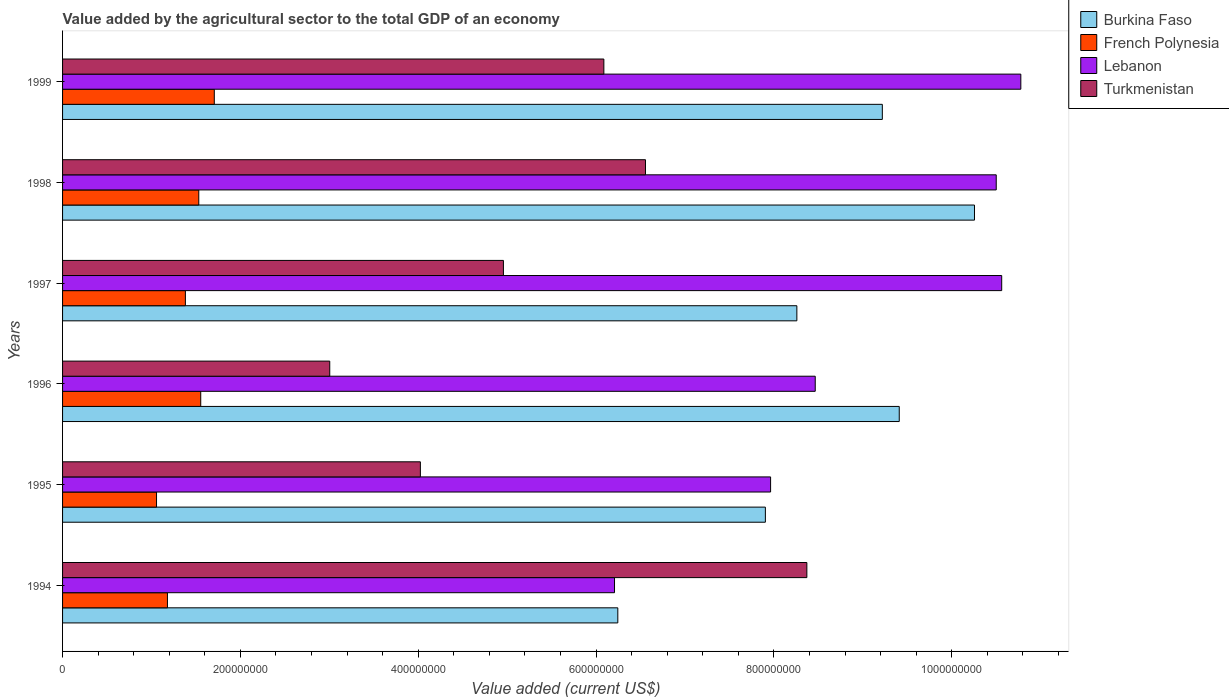How many different coloured bars are there?
Your answer should be very brief. 4. Are the number of bars per tick equal to the number of legend labels?
Keep it short and to the point. Yes. Are the number of bars on each tick of the Y-axis equal?
Your answer should be compact. Yes. How many bars are there on the 1st tick from the top?
Your response must be concise. 4. In how many cases, is the number of bars for a given year not equal to the number of legend labels?
Give a very brief answer. 0. What is the value added by the agricultural sector to the total GDP in Burkina Faso in 1995?
Offer a very short reply. 7.90e+08. Across all years, what is the maximum value added by the agricultural sector to the total GDP in French Polynesia?
Your answer should be compact. 1.71e+08. Across all years, what is the minimum value added by the agricultural sector to the total GDP in French Polynesia?
Provide a short and direct response. 1.06e+08. What is the total value added by the agricultural sector to the total GDP in French Polynesia in the graph?
Give a very brief answer. 8.41e+08. What is the difference between the value added by the agricultural sector to the total GDP in French Polynesia in 1998 and that in 1999?
Offer a very short reply. -1.75e+07. What is the difference between the value added by the agricultural sector to the total GDP in Burkina Faso in 1998 and the value added by the agricultural sector to the total GDP in Turkmenistan in 1999?
Ensure brevity in your answer.  4.17e+08. What is the average value added by the agricultural sector to the total GDP in Burkina Faso per year?
Make the answer very short. 8.55e+08. In the year 1998, what is the difference between the value added by the agricultural sector to the total GDP in Turkmenistan and value added by the agricultural sector to the total GDP in Burkina Faso?
Your answer should be compact. -3.70e+08. In how many years, is the value added by the agricultural sector to the total GDP in Turkmenistan greater than 960000000 US$?
Ensure brevity in your answer.  0. What is the ratio of the value added by the agricultural sector to the total GDP in Lebanon in 1994 to that in 1997?
Give a very brief answer. 0.59. Is the value added by the agricultural sector to the total GDP in French Polynesia in 1994 less than that in 1997?
Keep it short and to the point. Yes. What is the difference between the highest and the second highest value added by the agricultural sector to the total GDP in Burkina Faso?
Your response must be concise. 8.46e+07. What is the difference between the highest and the lowest value added by the agricultural sector to the total GDP in French Polynesia?
Provide a short and direct response. 6.50e+07. Is the sum of the value added by the agricultural sector to the total GDP in Burkina Faso in 1997 and 1999 greater than the maximum value added by the agricultural sector to the total GDP in Turkmenistan across all years?
Make the answer very short. Yes. What does the 1st bar from the top in 1999 represents?
Provide a succinct answer. Turkmenistan. What does the 3rd bar from the bottom in 1997 represents?
Your answer should be very brief. Lebanon. Are all the bars in the graph horizontal?
Make the answer very short. Yes. What is the difference between two consecutive major ticks on the X-axis?
Offer a terse response. 2.00e+08. Are the values on the major ticks of X-axis written in scientific E-notation?
Keep it short and to the point. No. Does the graph contain grids?
Offer a terse response. No. Where does the legend appear in the graph?
Give a very brief answer. Top right. What is the title of the graph?
Keep it short and to the point. Value added by the agricultural sector to the total GDP of an economy. What is the label or title of the X-axis?
Your answer should be very brief. Value added (current US$). What is the Value added (current US$) of Burkina Faso in 1994?
Your answer should be compact. 6.24e+08. What is the Value added (current US$) of French Polynesia in 1994?
Your response must be concise. 1.18e+08. What is the Value added (current US$) of Lebanon in 1994?
Offer a very short reply. 6.21e+08. What is the Value added (current US$) in Turkmenistan in 1994?
Provide a short and direct response. 8.37e+08. What is the Value added (current US$) in Burkina Faso in 1995?
Offer a very short reply. 7.90e+08. What is the Value added (current US$) of French Polynesia in 1995?
Provide a succinct answer. 1.06e+08. What is the Value added (current US$) of Lebanon in 1995?
Offer a terse response. 7.96e+08. What is the Value added (current US$) of Turkmenistan in 1995?
Your response must be concise. 4.02e+08. What is the Value added (current US$) of Burkina Faso in 1996?
Offer a terse response. 9.41e+08. What is the Value added (current US$) in French Polynesia in 1996?
Provide a short and direct response. 1.55e+08. What is the Value added (current US$) in Lebanon in 1996?
Offer a very short reply. 8.46e+08. What is the Value added (current US$) in Turkmenistan in 1996?
Your answer should be compact. 3.00e+08. What is the Value added (current US$) in Burkina Faso in 1997?
Offer a terse response. 8.26e+08. What is the Value added (current US$) of French Polynesia in 1997?
Ensure brevity in your answer.  1.38e+08. What is the Value added (current US$) of Lebanon in 1997?
Offer a terse response. 1.06e+09. What is the Value added (current US$) in Turkmenistan in 1997?
Provide a succinct answer. 4.96e+08. What is the Value added (current US$) in Burkina Faso in 1998?
Your answer should be compact. 1.03e+09. What is the Value added (current US$) in French Polynesia in 1998?
Ensure brevity in your answer.  1.53e+08. What is the Value added (current US$) in Lebanon in 1998?
Keep it short and to the point. 1.05e+09. What is the Value added (current US$) of Turkmenistan in 1998?
Make the answer very short. 6.56e+08. What is the Value added (current US$) of Burkina Faso in 1999?
Ensure brevity in your answer.  9.22e+08. What is the Value added (current US$) of French Polynesia in 1999?
Give a very brief answer. 1.71e+08. What is the Value added (current US$) of Lebanon in 1999?
Keep it short and to the point. 1.08e+09. What is the Value added (current US$) in Turkmenistan in 1999?
Keep it short and to the point. 6.09e+08. Across all years, what is the maximum Value added (current US$) in Burkina Faso?
Keep it short and to the point. 1.03e+09. Across all years, what is the maximum Value added (current US$) of French Polynesia?
Offer a very short reply. 1.71e+08. Across all years, what is the maximum Value added (current US$) of Lebanon?
Make the answer very short. 1.08e+09. Across all years, what is the maximum Value added (current US$) of Turkmenistan?
Your answer should be very brief. 8.37e+08. Across all years, what is the minimum Value added (current US$) in Burkina Faso?
Give a very brief answer. 6.24e+08. Across all years, what is the minimum Value added (current US$) of French Polynesia?
Make the answer very short. 1.06e+08. Across all years, what is the minimum Value added (current US$) of Lebanon?
Your response must be concise. 6.21e+08. Across all years, what is the minimum Value added (current US$) of Turkmenistan?
Your response must be concise. 3.00e+08. What is the total Value added (current US$) in Burkina Faso in the graph?
Offer a terse response. 5.13e+09. What is the total Value added (current US$) in French Polynesia in the graph?
Offer a very short reply. 8.41e+08. What is the total Value added (current US$) in Lebanon in the graph?
Your answer should be compact. 5.45e+09. What is the total Value added (current US$) in Turkmenistan in the graph?
Keep it short and to the point. 3.30e+09. What is the difference between the Value added (current US$) in Burkina Faso in 1994 and that in 1995?
Your answer should be very brief. -1.66e+08. What is the difference between the Value added (current US$) of French Polynesia in 1994 and that in 1995?
Your response must be concise. 1.23e+07. What is the difference between the Value added (current US$) in Lebanon in 1994 and that in 1995?
Your answer should be very brief. -1.76e+08. What is the difference between the Value added (current US$) of Turkmenistan in 1994 and that in 1995?
Offer a very short reply. 4.35e+08. What is the difference between the Value added (current US$) of Burkina Faso in 1994 and that in 1996?
Give a very brief answer. -3.17e+08. What is the difference between the Value added (current US$) in French Polynesia in 1994 and that in 1996?
Keep it short and to the point. -3.74e+07. What is the difference between the Value added (current US$) of Lebanon in 1994 and that in 1996?
Ensure brevity in your answer.  -2.26e+08. What is the difference between the Value added (current US$) in Turkmenistan in 1994 and that in 1996?
Provide a succinct answer. 5.37e+08. What is the difference between the Value added (current US$) of Burkina Faso in 1994 and that in 1997?
Provide a succinct answer. -2.01e+08. What is the difference between the Value added (current US$) in French Polynesia in 1994 and that in 1997?
Make the answer very short. -2.02e+07. What is the difference between the Value added (current US$) in Lebanon in 1994 and that in 1997?
Your answer should be very brief. -4.35e+08. What is the difference between the Value added (current US$) of Turkmenistan in 1994 and that in 1997?
Give a very brief answer. 3.41e+08. What is the difference between the Value added (current US$) of Burkina Faso in 1994 and that in 1998?
Your answer should be very brief. -4.01e+08. What is the difference between the Value added (current US$) of French Polynesia in 1994 and that in 1998?
Ensure brevity in your answer.  -3.52e+07. What is the difference between the Value added (current US$) in Lebanon in 1994 and that in 1998?
Keep it short and to the point. -4.29e+08. What is the difference between the Value added (current US$) of Turkmenistan in 1994 and that in 1998?
Your answer should be very brief. 1.81e+08. What is the difference between the Value added (current US$) in Burkina Faso in 1994 and that in 1999?
Provide a succinct answer. -2.97e+08. What is the difference between the Value added (current US$) in French Polynesia in 1994 and that in 1999?
Your answer should be very brief. -5.27e+07. What is the difference between the Value added (current US$) of Lebanon in 1994 and that in 1999?
Offer a terse response. -4.57e+08. What is the difference between the Value added (current US$) in Turkmenistan in 1994 and that in 1999?
Make the answer very short. 2.28e+08. What is the difference between the Value added (current US$) of Burkina Faso in 1995 and that in 1996?
Make the answer very short. -1.51e+08. What is the difference between the Value added (current US$) in French Polynesia in 1995 and that in 1996?
Your answer should be very brief. -4.97e+07. What is the difference between the Value added (current US$) in Lebanon in 1995 and that in 1996?
Your answer should be very brief. -5.02e+07. What is the difference between the Value added (current US$) in Turkmenistan in 1995 and that in 1996?
Provide a succinct answer. 1.02e+08. What is the difference between the Value added (current US$) of Burkina Faso in 1995 and that in 1997?
Keep it short and to the point. -3.54e+07. What is the difference between the Value added (current US$) in French Polynesia in 1995 and that in 1997?
Give a very brief answer. -3.25e+07. What is the difference between the Value added (current US$) of Lebanon in 1995 and that in 1997?
Provide a succinct answer. -2.60e+08. What is the difference between the Value added (current US$) in Turkmenistan in 1995 and that in 1997?
Offer a terse response. -9.34e+07. What is the difference between the Value added (current US$) in Burkina Faso in 1995 and that in 1998?
Offer a very short reply. -2.35e+08. What is the difference between the Value added (current US$) in French Polynesia in 1995 and that in 1998?
Give a very brief answer. -4.75e+07. What is the difference between the Value added (current US$) of Lebanon in 1995 and that in 1998?
Your response must be concise. -2.54e+08. What is the difference between the Value added (current US$) in Turkmenistan in 1995 and that in 1998?
Give a very brief answer. -2.53e+08. What is the difference between the Value added (current US$) of Burkina Faso in 1995 and that in 1999?
Provide a short and direct response. -1.32e+08. What is the difference between the Value added (current US$) in French Polynesia in 1995 and that in 1999?
Give a very brief answer. -6.50e+07. What is the difference between the Value added (current US$) in Lebanon in 1995 and that in 1999?
Offer a terse response. -2.81e+08. What is the difference between the Value added (current US$) of Turkmenistan in 1995 and that in 1999?
Provide a short and direct response. -2.06e+08. What is the difference between the Value added (current US$) of Burkina Faso in 1996 and that in 1997?
Provide a succinct answer. 1.15e+08. What is the difference between the Value added (current US$) in French Polynesia in 1996 and that in 1997?
Provide a short and direct response. 1.73e+07. What is the difference between the Value added (current US$) in Lebanon in 1996 and that in 1997?
Ensure brevity in your answer.  -2.10e+08. What is the difference between the Value added (current US$) in Turkmenistan in 1996 and that in 1997?
Your response must be concise. -1.95e+08. What is the difference between the Value added (current US$) of Burkina Faso in 1996 and that in 1998?
Provide a short and direct response. -8.46e+07. What is the difference between the Value added (current US$) in French Polynesia in 1996 and that in 1998?
Your response must be concise. 2.21e+06. What is the difference between the Value added (current US$) in Lebanon in 1996 and that in 1998?
Offer a very short reply. -2.04e+08. What is the difference between the Value added (current US$) in Turkmenistan in 1996 and that in 1998?
Offer a terse response. -3.55e+08. What is the difference between the Value added (current US$) in Burkina Faso in 1996 and that in 1999?
Offer a very short reply. 1.90e+07. What is the difference between the Value added (current US$) of French Polynesia in 1996 and that in 1999?
Your answer should be very brief. -1.52e+07. What is the difference between the Value added (current US$) in Lebanon in 1996 and that in 1999?
Offer a very short reply. -2.31e+08. What is the difference between the Value added (current US$) in Turkmenistan in 1996 and that in 1999?
Keep it short and to the point. -3.08e+08. What is the difference between the Value added (current US$) in Burkina Faso in 1997 and that in 1998?
Your answer should be very brief. -2.00e+08. What is the difference between the Value added (current US$) of French Polynesia in 1997 and that in 1998?
Provide a short and direct response. -1.50e+07. What is the difference between the Value added (current US$) in Lebanon in 1997 and that in 1998?
Your answer should be very brief. 6.15e+06. What is the difference between the Value added (current US$) in Turkmenistan in 1997 and that in 1998?
Offer a terse response. -1.60e+08. What is the difference between the Value added (current US$) of Burkina Faso in 1997 and that in 1999?
Provide a short and direct response. -9.61e+07. What is the difference between the Value added (current US$) in French Polynesia in 1997 and that in 1999?
Keep it short and to the point. -3.25e+07. What is the difference between the Value added (current US$) of Lebanon in 1997 and that in 1999?
Ensure brevity in your answer.  -2.15e+07. What is the difference between the Value added (current US$) of Turkmenistan in 1997 and that in 1999?
Ensure brevity in your answer.  -1.13e+08. What is the difference between the Value added (current US$) of Burkina Faso in 1998 and that in 1999?
Give a very brief answer. 1.04e+08. What is the difference between the Value added (current US$) of French Polynesia in 1998 and that in 1999?
Your answer should be compact. -1.75e+07. What is the difference between the Value added (current US$) in Lebanon in 1998 and that in 1999?
Your response must be concise. -2.77e+07. What is the difference between the Value added (current US$) in Turkmenistan in 1998 and that in 1999?
Ensure brevity in your answer.  4.68e+07. What is the difference between the Value added (current US$) in Burkina Faso in 1994 and the Value added (current US$) in French Polynesia in 1995?
Give a very brief answer. 5.19e+08. What is the difference between the Value added (current US$) in Burkina Faso in 1994 and the Value added (current US$) in Lebanon in 1995?
Offer a terse response. -1.72e+08. What is the difference between the Value added (current US$) of Burkina Faso in 1994 and the Value added (current US$) of Turkmenistan in 1995?
Ensure brevity in your answer.  2.22e+08. What is the difference between the Value added (current US$) in French Polynesia in 1994 and the Value added (current US$) in Lebanon in 1995?
Make the answer very short. -6.78e+08. What is the difference between the Value added (current US$) of French Polynesia in 1994 and the Value added (current US$) of Turkmenistan in 1995?
Keep it short and to the point. -2.84e+08. What is the difference between the Value added (current US$) of Lebanon in 1994 and the Value added (current US$) of Turkmenistan in 1995?
Ensure brevity in your answer.  2.18e+08. What is the difference between the Value added (current US$) in Burkina Faso in 1994 and the Value added (current US$) in French Polynesia in 1996?
Give a very brief answer. 4.69e+08. What is the difference between the Value added (current US$) in Burkina Faso in 1994 and the Value added (current US$) in Lebanon in 1996?
Provide a succinct answer. -2.22e+08. What is the difference between the Value added (current US$) of Burkina Faso in 1994 and the Value added (current US$) of Turkmenistan in 1996?
Keep it short and to the point. 3.24e+08. What is the difference between the Value added (current US$) of French Polynesia in 1994 and the Value added (current US$) of Lebanon in 1996?
Provide a succinct answer. -7.29e+08. What is the difference between the Value added (current US$) in French Polynesia in 1994 and the Value added (current US$) in Turkmenistan in 1996?
Provide a short and direct response. -1.83e+08. What is the difference between the Value added (current US$) in Lebanon in 1994 and the Value added (current US$) in Turkmenistan in 1996?
Give a very brief answer. 3.20e+08. What is the difference between the Value added (current US$) in Burkina Faso in 1994 and the Value added (current US$) in French Polynesia in 1997?
Give a very brief answer. 4.86e+08. What is the difference between the Value added (current US$) of Burkina Faso in 1994 and the Value added (current US$) of Lebanon in 1997?
Offer a terse response. -4.32e+08. What is the difference between the Value added (current US$) in Burkina Faso in 1994 and the Value added (current US$) in Turkmenistan in 1997?
Give a very brief answer. 1.29e+08. What is the difference between the Value added (current US$) of French Polynesia in 1994 and the Value added (current US$) of Lebanon in 1997?
Provide a short and direct response. -9.38e+08. What is the difference between the Value added (current US$) in French Polynesia in 1994 and the Value added (current US$) in Turkmenistan in 1997?
Give a very brief answer. -3.78e+08. What is the difference between the Value added (current US$) of Lebanon in 1994 and the Value added (current US$) of Turkmenistan in 1997?
Make the answer very short. 1.25e+08. What is the difference between the Value added (current US$) in Burkina Faso in 1994 and the Value added (current US$) in French Polynesia in 1998?
Make the answer very short. 4.71e+08. What is the difference between the Value added (current US$) of Burkina Faso in 1994 and the Value added (current US$) of Lebanon in 1998?
Make the answer very short. -4.26e+08. What is the difference between the Value added (current US$) in Burkina Faso in 1994 and the Value added (current US$) in Turkmenistan in 1998?
Ensure brevity in your answer.  -3.11e+07. What is the difference between the Value added (current US$) of French Polynesia in 1994 and the Value added (current US$) of Lebanon in 1998?
Offer a very short reply. -9.32e+08. What is the difference between the Value added (current US$) of French Polynesia in 1994 and the Value added (current US$) of Turkmenistan in 1998?
Provide a succinct answer. -5.38e+08. What is the difference between the Value added (current US$) of Lebanon in 1994 and the Value added (current US$) of Turkmenistan in 1998?
Ensure brevity in your answer.  -3.48e+07. What is the difference between the Value added (current US$) of Burkina Faso in 1994 and the Value added (current US$) of French Polynesia in 1999?
Keep it short and to the point. 4.54e+08. What is the difference between the Value added (current US$) in Burkina Faso in 1994 and the Value added (current US$) in Lebanon in 1999?
Offer a very short reply. -4.53e+08. What is the difference between the Value added (current US$) in Burkina Faso in 1994 and the Value added (current US$) in Turkmenistan in 1999?
Offer a terse response. 1.57e+07. What is the difference between the Value added (current US$) in French Polynesia in 1994 and the Value added (current US$) in Lebanon in 1999?
Your answer should be very brief. -9.60e+08. What is the difference between the Value added (current US$) of French Polynesia in 1994 and the Value added (current US$) of Turkmenistan in 1999?
Provide a short and direct response. -4.91e+08. What is the difference between the Value added (current US$) in Lebanon in 1994 and the Value added (current US$) in Turkmenistan in 1999?
Provide a short and direct response. 1.20e+07. What is the difference between the Value added (current US$) of Burkina Faso in 1995 and the Value added (current US$) of French Polynesia in 1996?
Offer a very short reply. 6.35e+08. What is the difference between the Value added (current US$) in Burkina Faso in 1995 and the Value added (current US$) in Lebanon in 1996?
Give a very brief answer. -5.61e+07. What is the difference between the Value added (current US$) in Burkina Faso in 1995 and the Value added (current US$) in Turkmenistan in 1996?
Ensure brevity in your answer.  4.90e+08. What is the difference between the Value added (current US$) in French Polynesia in 1995 and the Value added (current US$) in Lebanon in 1996?
Give a very brief answer. -7.41e+08. What is the difference between the Value added (current US$) of French Polynesia in 1995 and the Value added (current US$) of Turkmenistan in 1996?
Make the answer very short. -1.95e+08. What is the difference between the Value added (current US$) in Lebanon in 1995 and the Value added (current US$) in Turkmenistan in 1996?
Give a very brief answer. 4.96e+08. What is the difference between the Value added (current US$) in Burkina Faso in 1995 and the Value added (current US$) in French Polynesia in 1997?
Make the answer very short. 6.52e+08. What is the difference between the Value added (current US$) of Burkina Faso in 1995 and the Value added (current US$) of Lebanon in 1997?
Your response must be concise. -2.66e+08. What is the difference between the Value added (current US$) of Burkina Faso in 1995 and the Value added (current US$) of Turkmenistan in 1997?
Your answer should be very brief. 2.95e+08. What is the difference between the Value added (current US$) of French Polynesia in 1995 and the Value added (current US$) of Lebanon in 1997?
Your answer should be compact. -9.51e+08. What is the difference between the Value added (current US$) in French Polynesia in 1995 and the Value added (current US$) in Turkmenistan in 1997?
Provide a succinct answer. -3.90e+08. What is the difference between the Value added (current US$) in Lebanon in 1995 and the Value added (current US$) in Turkmenistan in 1997?
Ensure brevity in your answer.  3.00e+08. What is the difference between the Value added (current US$) in Burkina Faso in 1995 and the Value added (current US$) in French Polynesia in 1998?
Give a very brief answer. 6.37e+08. What is the difference between the Value added (current US$) in Burkina Faso in 1995 and the Value added (current US$) in Lebanon in 1998?
Offer a very short reply. -2.60e+08. What is the difference between the Value added (current US$) in Burkina Faso in 1995 and the Value added (current US$) in Turkmenistan in 1998?
Offer a very short reply. 1.35e+08. What is the difference between the Value added (current US$) of French Polynesia in 1995 and the Value added (current US$) of Lebanon in 1998?
Ensure brevity in your answer.  -9.44e+08. What is the difference between the Value added (current US$) in French Polynesia in 1995 and the Value added (current US$) in Turkmenistan in 1998?
Give a very brief answer. -5.50e+08. What is the difference between the Value added (current US$) in Lebanon in 1995 and the Value added (current US$) in Turkmenistan in 1998?
Your answer should be very brief. 1.41e+08. What is the difference between the Value added (current US$) of Burkina Faso in 1995 and the Value added (current US$) of French Polynesia in 1999?
Your answer should be very brief. 6.20e+08. What is the difference between the Value added (current US$) in Burkina Faso in 1995 and the Value added (current US$) in Lebanon in 1999?
Give a very brief answer. -2.87e+08. What is the difference between the Value added (current US$) of Burkina Faso in 1995 and the Value added (current US$) of Turkmenistan in 1999?
Ensure brevity in your answer.  1.82e+08. What is the difference between the Value added (current US$) in French Polynesia in 1995 and the Value added (current US$) in Lebanon in 1999?
Provide a succinct answer. -9.72e+08. What is the difference between the Value added (current US$) in French Polynesia in 1995 and the Value added (current US$) in Turkmenistan in 1999?
Provide a succinct answer. -5.03e+08. What is the difference between the Value added (current US$) in Lebanon in 1995 and the Value added (current US$) in Turkmenistan in 1999?
Your answer should be compact. 1.88e+08. What is the difference between the Value added (current US$) in Burkina Faso in 1996 and the Value added (current US$) in French Polynesia in 1997?
Offer a very short reply. 8.03e+08. What is the difference between the Value added (current US$) of Burkina Faso in 1996 and the Value added (current US$) of Lebanon in 1997?
Make the answer very short. -1.15e+08. What is the difference between the Value added (current US$) of Burkina Faso in 1996 and the Value added (current US$) of Turkmenistan in 1997?
Offer a very short reply. 4.45e+08. What is the difference between the Value added (current US$) in French Polynesia in 1996 and the Value added (current US$) in Lebanon in 1997?
Give a very brief answer. -9.01e+08. What is the difference between the Value added (current US$) in French Polynesia in 1996 and the Value added (current US$) in Turkmenistan in 1997?
Your response must be concise. -3.40e+08. What is the difference between the Value added (current US$) in Lebanon in 1996 and the Value added (current US$) in Turkmenistan in 1997?
Offer a terse response. 3.51e+08. What is the difference between the Value added (current US$) of Burkina Faso in 1996 and the Value added (current US$) of French Polynesia in 1998?
Provide a succinct answer. 7.88e+08. What is the difference between the Value added (current US$) in Burkina Faso in 1996 and the Value added (current US$) in Lebanon in 1998?
Ensure brevity in your answer.  -1.09e+08. What is the difference between the Value added (current US$) of Burkina Faso in 1996 and the Value added (current US$) of Turkmenistan in 1998?
Ensure brevity in your answer.  2.85e+08. What is the difference between the Value added (current US$) in French Polynesia in 1996 and the Value added (current US$) in Lebanon in 1998?
Your response must be concise. -8.95e+08. What is the difference between the Value added (current US$) in French Polynesia in 1996 and the Value added (current US$) in Turkmenistan in 1998?
Make the answer very short. -5.00e+08. What is the difference between the Value added (current US$) of Lebanon in 1996 and the Value added (current US$) of Turkmenistan in 1998?
Offer a very short reply. 1.91e+08. What is the difference between the Value added (current US$) of Burkina Faso in 1996 and the Value added (current US$) of French Polynesia in 1999?
Your answer should be compact. 7.70e+08. What is the difference between the Value added (current US$) of Burkina Faso in 1996 and the Value added (current US$) of Lebanon in 1999?
Give a very brief answer. -1.37e+08. What is the difference between the Value added (current US$) in Burkina Faso in 1996 and the Value added (current US$) in Turkmenistan in 1999?
Your answer should be compact. 3.32e+08. What is the difference between the Value added (current US$) of French Polynesia in 1996 and the Value added (current US$) of Lebanon in 1999?
Ensure brevity in your answer.  -9.22e+08. What is the difference between the Value added (current US$) of French Polynesia in 1996 and the Value added (current US$) of Turkmenistan in 1999?
Your answer should be compact. -4.53e+08. What is the difference between the Value added (current US$) in Lebanon in 1996 and the Value added (current US$) in Turkmenistan in 1999?
Provide a short and direct response. 2.38e+08. What is the difference between the Value added (current US$) of Burkina Faso in 1997 and the Value added (current US$) of French Polynesia in 1998?
Provide a short and direct response. 6.73e+08. What is the difference between the Value added (current US$) in Burkina Faso in 1997 and the Value added (current US$) in Lebanon in 1998?
Provide a succinct answer. -2.24e+08. What is the difference between the Value added (current US$) of Burkina Faso in 1997 and the Value added (current US$) of Turkmenistan in 1998?
Ensure brevity in your answer.  1.70e+08. What is the difference between the Value added (current US$) in French Polynesia in 1997 and the Value added (current US$) in Lebanon in 1998?
Your answer should be compact. -9.12e+08. What is the difference between the Value added (current US$) of French Polynesia in 1997 and the Value added (current US$) of Turkmenistan in 1998?
Offer a terse response. -5.17e+08. What is the difference between the Value added (current US$) of Lebanon in 1997 and the Value added (current US$) of Turkmenistan in 1998?
Your answer should be very brief. 4.01e+08. What is the difference between the Value added (current US$) in Burkina Faso in 1997 and the Value added (current US$) in French Polynesia in 1999?
Give a very brief answer. 6.55e+08. What is the difference between the Value added (current US$) of Burkina Faso in 1997 and the Value added (current US$) of Lebanon in 1999?
Your response must be concise. -2.52e+08. What is the difference between the Value added (current US$) in Burkina Faso in 1997 and the Value added (current US$) in Turkmenistan in 1999?
Offer a very short reply. 2.17e+08. What is the difference between the Value added (current US$) in French Polynesia in 1997 and the Value added (current US$) in Lebanon in 1999?
Give a very brief answer. -9.40e+08. What is the difference between the Value added (current US$) of French Polynesia in 1997 and the Value added (current US$) of Turkmenistan in 1999?
Your answer should be very brief. -4.71e+08. What is the difference between the Value added (current US$) of Lebanon in 1997 and the Value added (current US$) of Turkmenistan in 1999?
Your response must be concise. 4.47e+08. What is the difference between the Value added (current US$) of Burkina Faso in 1998 and the Value added (current US$) of French Polynesia in 1999?
Offer a very short reply. 8.55e+08. What is the difference between the Value added (current US$) in Burkina Faso in 1998 and the Value added (current US$) in Lebanon in 1999?
Provide a short and direct response. -5.21e+07. What is the difference between the Value added (current US$) of Burkina Faso in 1998 and the Value added (current US$) of Turkmenistan in 1999?
Make the answer very short. 4.17e+08. What is the difference between the Value added (current US$) of French Polynesia in 1998 and the Value added (current US$) of Lebanon in 1999?
Provide a short and direct response. -9.25e+08. What is the difference between the Value added (current US$) in French Polynesia in 1998 and the Value added (current US$) in Turkmenistan in 1999?
Offer a very short reply. -4.56e+08. What is the difference between the Value added (current US$) of Lebanon in 1998 and the Value added (current US$) of Turkmenistan in 1999?
Make the answer very short. 4.41e+08. What is the average Value added (current US$) of Burkina Faso per year?
Your answer should be compact. 8.55e+08. What is the average Value added (current US$) in French Polynesia per year?
Make the answer very short. 1.40e+08. What is the average Value added (current US$) in Lebanon per year?
Your answer should be compact. 9.08e+08. What is the average Value added (current US$) in Turkmenistan per year?
Provide a short and direct response. 5.50e+08. In the year 1994, what is the difference between the Value added (current US$) of Burkina Faso and Value added (current US$) of French Polynesia?
Provide a short and direct response. 5.06e+08. In the year 1994, what is the difference between the Value added (current US$) of Burkina Faso and Value added (current US$) of Lebanon?
Offer a terse response. 3.72e+06. In the year 1994, what is the difference between the Value added (current US$) of Burkina Faso and Value added (current US$) of Turkmenistan?
Keep it short and to the point. -2.13e+08. In the year 1994, what is the difference between the Value added (current US$) in French Polynesia and Value added (current US$) in Lebanon?
Your response must be concise. -5.03e+08. In the year 1994, what is the difference between the Value added (current US$) of French Polynesia and Value added (current US$) of Turkmenistan?
Your response must be concise. -7.19e+08. In the year 1994, what is the difference between the Value added (current US$) of Lebanon and Value added (current US$) of Turkmenistan?
Provide a succinct answer. -2.16e+08. In the year 1995, what is the difference between the Value added (current US$) in Burkina Faso and Value added (current US$) in French Polynesia?
Your answer should be very brief. 6.85e+08. In the year 1995, what is the difference between the Value added (current US$) in Burkina Faso and Value added (current US$) in Lebanon?
Your answer should be compact. -5.87e+06. In the year 1995, what is the difference between the Value added (current US$) of Burkina Faso and Value added (current US$) of Turkmenistan?
Ensure brevity in your answer.  3.88e+08. In the year 1995, what is the difference between the Value added (current US$) of French Polynesia and Value added (current US$) of Lebanon?
Your response must be concise. -6.91e+08. In the year 1995, what is the difference between the Value added (current US$) in French Polynesia and Value added (current US$) in Turkmenistan?
Ensure brevity in your answer.  -2.97e+08. In the year 1995, what is the difference between the Value added (current US$) of Lebanon and Value added (current US$) of Turkmenistan?
Offer a very short reply. 3.94e+08. In the year 1996, what is the difference between the Value added (current US$) of Burkina Faso and Value added (current US$) of French Polynesia?
Your answer should be very brief. 7.86e+08. In the year 1996, what is the difference between the Value added (current US$) in Burkina Faso and Value added (current US$) in Lebanon?
Keep it short and to the point. 9.45e+07. In the year 1996, what is the difference between the Value added (current US$) in Burkina Faso and Value added (current US$) in Turkmenistan?
Offer a very short reply. 6.40e+08. In the year 1996, what is the difference between the Value added (current US$) in French Polynesia and Value added (current US$) in Lebanon?
Offer a terse response. -6.91e+08. In the year 1996, what is the difference between the Value added (current US$) in French Polynesia and Value added (current US$) in Turkmenistan?
Offer a very short reply. -1.45e+08. In the year 1996, what is the difference between the Value added (current US$) of Lebanon and Value added (current US$) of Turkmenistan?
Provide a succinct answer. 5.46e+08. In the year 1997, what is the difference between the Value added (current US$) in Burkina Faso and Value added (current US$) in French Polynesia?
Your answer should be very brief. 6.88e+08. In the year 1997, what is the difference between the Value added (current US$) in Burkina Faso and Value added (current US$) in Lebanon?
Give a very brief answer. -2.30e+08. In the year 1997, what is the difference between the Value added (current US$) of Burkina Faso and Value added (current US$) of Turkmenistan?
Your response must be concise. 3.30e+08. In the year 1997, what is the difference between the Value added (current US$) in French Polynesia and Value added (current US$) in Lebanon?
Keep it short and to the point. -9.18e+08. In the year 1997, what is the difference between the Value added (current US$) in French Polynesia and Value added (current US$) in Turkmenistan?
Your answer should be very brief. -3.58e+08. In the year 1997, what is the difference between the Value added (current US$) in Lebanon and Value added (current US$) in Turkmenistan?
Your response must be concise. 5.60e+08. In the year 1998, what is the difference between the Value added (current US$) of Burkina Faso and Value added (current US$) of French Polynesia?
Make the answer very short. 8.72e+08. In the year 1998, what is the difference between the Value added (current US$) of Burkina Faso and Value added (current US$) of Lebanon?
Give a very brief answer. -2.45e+07. In the year 1998, what is the difference between the Value added (current US$) of Burkina Faso and Value added (current US$) of Turkmenistan?
Provide a short and direct response. 3.70e+08. In the year 1998, what is the difference between the Value added (current US$) in French Polynesia and Value added (current US$) in Lebanon?
Provide a short and direct response. -8.97e+08. In the year 1998, what is the difference between the Value added (current US$) of French Polynesia and Value added (current US$) of Turkmenistan?
Your answer should be very brief. -5.02e+08. In the year 1998, what is the difference between the Value added (current US$) in Lebanon and Value added (current US$) in Turkmenistan?
Give a very brief answer. 3.94e+08. In the year 1999, what is the difference between the Value added (current US$) of Burkina Faso and Value added (current US$) of French Polynesia?
Offer a terse response. 7.51e+08. In the year 1999, what is the difference between the Value added (current US$) of Burkina Faso and Value added (current US$) of Lebanon?
Provide a short and direct response. -1.56e+08. In the year 1999, what is the difference between the Value added (current US$) in Burkina Faso and Value added (current US$) in Turkmenistan?
Provide a succinct answer. 3.13e+08. In the year 1999, what is the difference between the Value added (current US$) in French Polynesia and Value added (current US$) in Lebanon?
Make the answer very short. -9.07e+08. In the year 1999, what is the difference between the Value added (current US$) in French Polynesia and Value added (current US$) in Turkmenistan?
Make the answer very short. -4.38e+08. In the year 1999, what is the difference between the Value added (current US$) in Lebanon and Value added (current US$) in Turkmenistan?
Offer a terse response. 4.69e+08. What is the ratio of the Value added (current US$) of Burkina Faso in 1994 to that in 1995?
Ensure brevity in your answer.  0.79. What is the ratio of the Value added (current US$) of French Polynesia in 1994 to that in 1995?
Your answer should be compact. 1.12. What is the ratio of the Value added (current US$) of Lebanon in 1994 to that in 1995?
Provide a short and direct response. 0.78. What is the ratio of the Value added (current US$) in Turkmenistan in 1994 to that in 1995?
Provide a succinct answer. 2.08. What is the ratio of the Value added (current US$) in Burkina Faso in 1994 to that in 1996?
Provide a succinct answer. 0.66. What is the ratio of the Value added (current US$) of French Polynesia in 1994 to that in 1996?
Your response must be concise. 0.76. What is the ratio of the Value added (current US$) of Lebanon in 1994 to that in 1996?
Make the answer very short. 0.73. What is the ratio of the Value added (current US$) of Turkmenistan in 1994 to that in 1996?
Your answer should be compact. 2.79. What is the ratio of the Value added (current US$) in Burkina Faso in 1994 to that in 1997?
Your answer should be compact. 0.76. What is the ratio of the Value added (current US$) of French Polynesia in 1994 to that in 1997?
Ensure brevity in your answer.  0.85. What is the ratio of the Value added (current US$) of Lebanon in 1994 to that in 1997?
Your answer should be very brief. 0.59. What is the ratio of the Value added (current US$) of Turkmenistan in 1994 to that in 1997?
Offer a terse response. 1.69. What is the ratio of the Value added (current US$) in Burkina Faso in 1994 to that in 1998?
Your answer should be very brief. 0.61. What is the ratio of the Value added (current US$) in French Polynesia in 1994 to that in 1998?
Give a very brief answer. 0.77. What is the ratio of the Value added (current US$) of Lebanon in 1994 to that in 1998?
Your answer should be compact. 0.59. What is the ratio of the Value added (current US$) of Turkmenistan in 1994 to that in 1998?
Your answer should be compact. 1.28. What is the ratio of the Value added (current US$) in Burkina Faso in 1994 to that in 1999?
Ensure brevity in your answer.  0.68. What is the ratio of the Value added (current US$) of French Polynesia in 1994 to that in 1999?
Keep it short and to the point. 0.69. What is the ratio of the Value added (current US$) in Lebanon in 1994 to that in 1999?
Your answer should be very brief. 0.58. What is the ratio of the Value added (current US$) of Turkmenistan in 1994 to that in 1999?
Your answer should be very brief. 1.38. What is the ratio of the Value added (current US$) of Burkina Faso in 1995 to that in 1996?
Offer a very short reply. 0.84. What is the ratio of the Value added (current US$) of French Polynesia in 1995 to that in 1996?
Your answer should be very brief. 0.68. What is the ratio of the Value added (current US$) of Lebanon in 1995 to that in 1996?
Offer a very short reply. 0.94. What is the ratio of the Value added (current US$) in Turkmenistan in 1995 to that in 1996?
Your answer should be compact. 1.34. What is the ratio of the Value added (current US$) of Burkina Faso in 1995 to that in 1997?
Keep it short and to the point. 0.96. What is the ratio of the Value added (current US$) of French Polynesia in 1995 to that in 1997?
Provide a short and direct response. 0.77. What is the ratio of the Value added (current US$) of Lebanon in 1995 to that in 1997?
Keep it short and to the point. 0.75. What is the ratio of the Value added (current US$) of Turkmenistan in 1995 to that in 1997?
Provide a succinct answer. 0.81. What is the ratio of the Value added (current US$) in Burkina Faso in 1995 to that in 1998?
Make the answer very short. 0.77. What is the ratio of the Value added (current US$) in French Polynesia in 1995 to that in 1998?
Your answer should be very brief. 0.69. What is the ratio of the Value added (current US$) in Lebanon in 1995 to that in 1998?
Provide a short and direct response. 0.76. What is the ratio of the Value added (current US$) in Turkmenistan in 1995 to that in 1998?
Your answer should be very brief. 0.61. What is the ratio of the Value added (current US$) of Burkina Faso in 1995 to that in 1999?
Provide a short and direct response. 0.86. What is the ratio of the Value added (current US$) of French Polynesia in 1995 to that in 1999?
Keep it short and to the point. 0.62. What is the ratio of the Value added (current US$) of Lebanon in 1995 to that in 1999?
Offer a terse response. 0.74. What is the ratio of the Value added (current US$) in Turkmenistan in 1995 to that in 1999?
Your response must be concise. 0.66. What is the ratio of the Value added (current US$) in Burkina Faso in 1996 to that in 1997?
Your answer should be compact. 1.14. What is the ratio of the Value added (current US$) in French Polynesia in 1996 to that in 1997?
Your response must be concise. 1.12. What is the ratio of the Value added (current US$) of Lebanon in 1996 to that in 1997?
Make the answer very short. 0.8. What is the ratio of the Value added (current US$) in Turkmenistan in 1996 to that in 1997?
Make the answer very short. 0.61. What is the ratio of the Value added (current US$) of Burkina Faso in 1996 to that in 1998?
Offer a terse response. 0.92. What is the ratio of the Value added (current US$) in French Polynesia in 1996 to that in 1998?
Provide a succinct answer. 1.01. What is the ratio of the Value added (current US$) of Lebanon in 1996 to that in 1998?
Give a very brief answer. 0.81. What is the ratio of the Value added (current US$) of Turkmenistan in 1996 to that in 1998?
Give a very brief answer. 0.46. What is the ratio of the Value added (current US$) in Burkina Faso in 1996 to that in 1999?
Your response must be concise. 1.02. What is the ratio of the Value added (current US$) of French Polynesia in 1996 to that in 1999?
Keep it short and to the point. 0.91. What is the ratio of the Value added (current US$) of Lebanon in 1996 to that in 1999?
Make the answer very short. 0.79. What is the ratio of the Value added (current US$) of Turkmenistan in 1996 to that in 1999?
Keep it short and to the point. 0.49. What is the ratio of the Value added (current US$) of Burkina Faso in 1997 to that in 1998?
Offer a very short reply. 0.81. What is the ratio of the Value added (current US$) in French Polynesia in 1997 to that in 1998?
Keep it short and to the point. 0.9. What is the ratio of the Value added (current US$) of Lebanon in 1997 to that in 1998?
Keep it short and to the point. 1.01. What is the ratio of the Value added (current US$) in Turkmenistan in 1997 to that in 1998?
Your response must be concise. 0.76. What is the ratio of the Value added (current US$) of Burkina Faso in 1997 to that in 1999?
Provide a short and direct response. 0.9. What is the ratio of the Value added (current US$) in French Polynesia in 1997 to that in 1999?
Your answer should be very brief. 0.81. What is the ratio of the Value added (current US$) of Turkmenistan in 1997 to that in 1999?
Your response must be concise. 0.81. What is the ratio of the Value added (current US$) in Burkina Faso in 1998 to that in 1999?
Your answer should be compact. 1.11. What is the ratio of the Value added (current US$) in French Polynesia in 1998 to that in 1999?
Offer a terse response. 0.9. What is the ratio of the Value added (current US$) in Lebanon in 1998 to that in 1999?
Offer a terse response. 0.97. What is the difference between the highest and the second highest Value added (current US$) of Burkina Faso?
Give a very brief answer. 8.46e+07. What is the difference between the highest and the second highest Value added (current US$) in French Polynesia?
Your answer should be compact. 1.52e+07. What is the difference between the highest and the second highest Value added (current US$) of Lebanon?
Your response must be concise. 2.15e+07. What is the difference between the highest and the second highest Value added (current US$) in Turkmenistan?
Your answer should be compact. 1.81e+08. What is the difference between the highest and the lowest Value added (current US$) in Burkina Faso?
Your answer should be very brief. 4.01e+08. What is the difference between the highest and the lowest Value added (current US$) in French Polynesia?
Your response must be concise. 6.50e+07. What is the difference between the highest and the lowest Value added (current US$) in Lebanon?
Your answer should be very brief. 4.57e+08. What is the difference between the highest and the lowest Value added (current US$) in Turkmenistan?
Ensure brevity in your answer.  5.37e+08. 